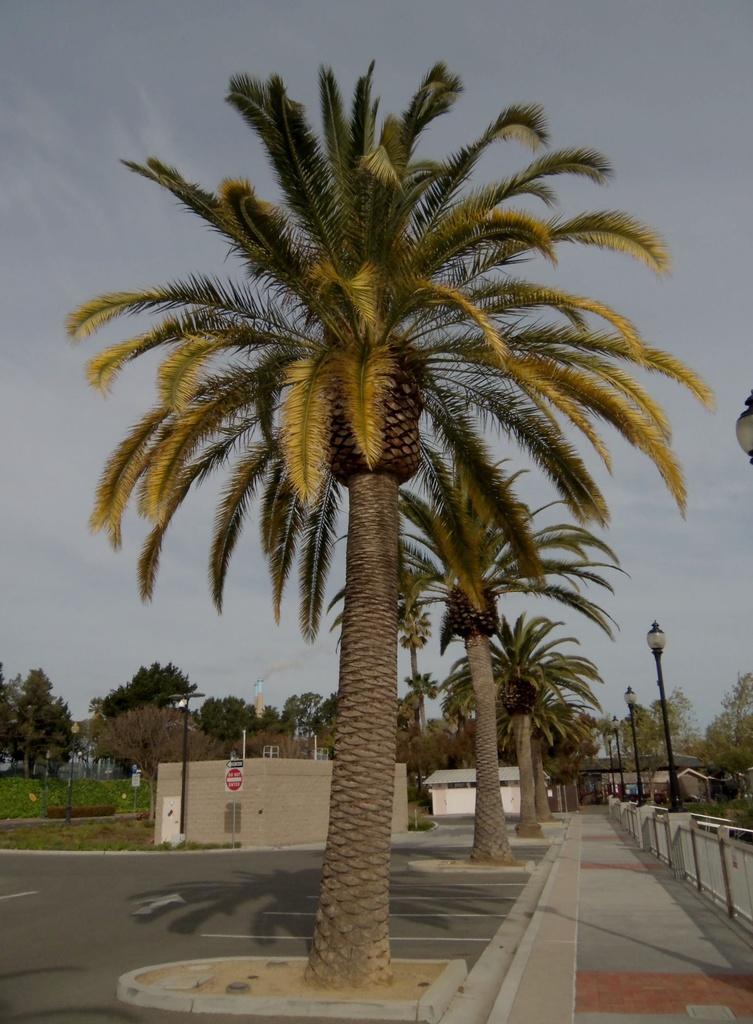How would you summarize this image in a sentence or two? In this image I can see a trees,signboard and light poles. Back I can see a house and fencing. The sky is in blue and white color. 